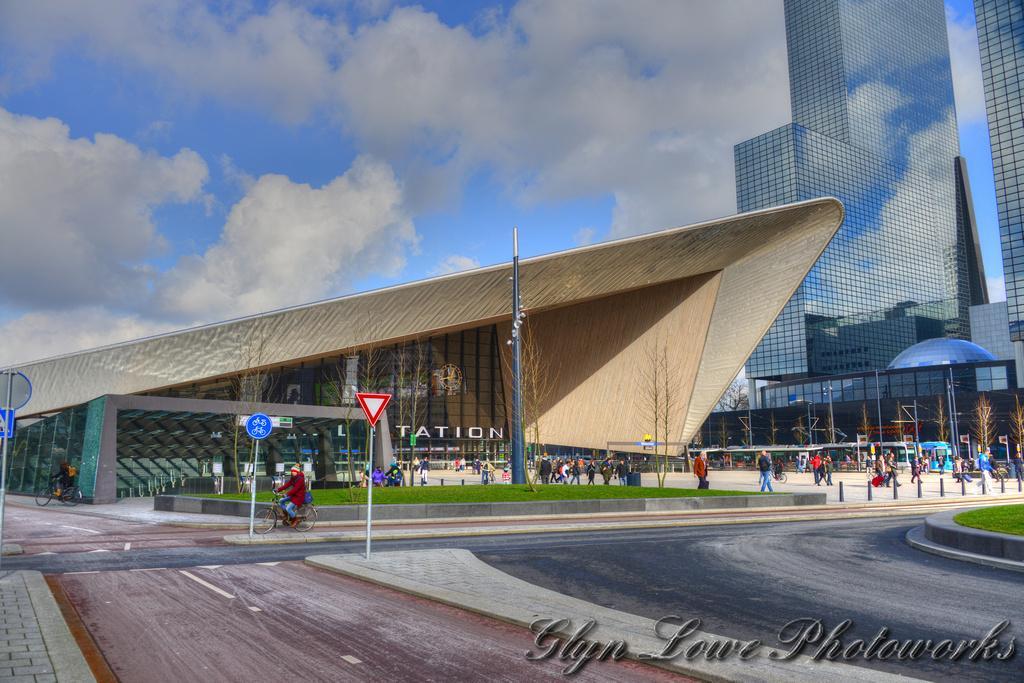Could you give a brief overview of what you see in this image? The picture looks like it is edited. In the foreground we can see road, grass, boards and a person on bicycle. In the middle of the picture there are buildings, people, trees, poles and various other objects. At the top there is sky. 